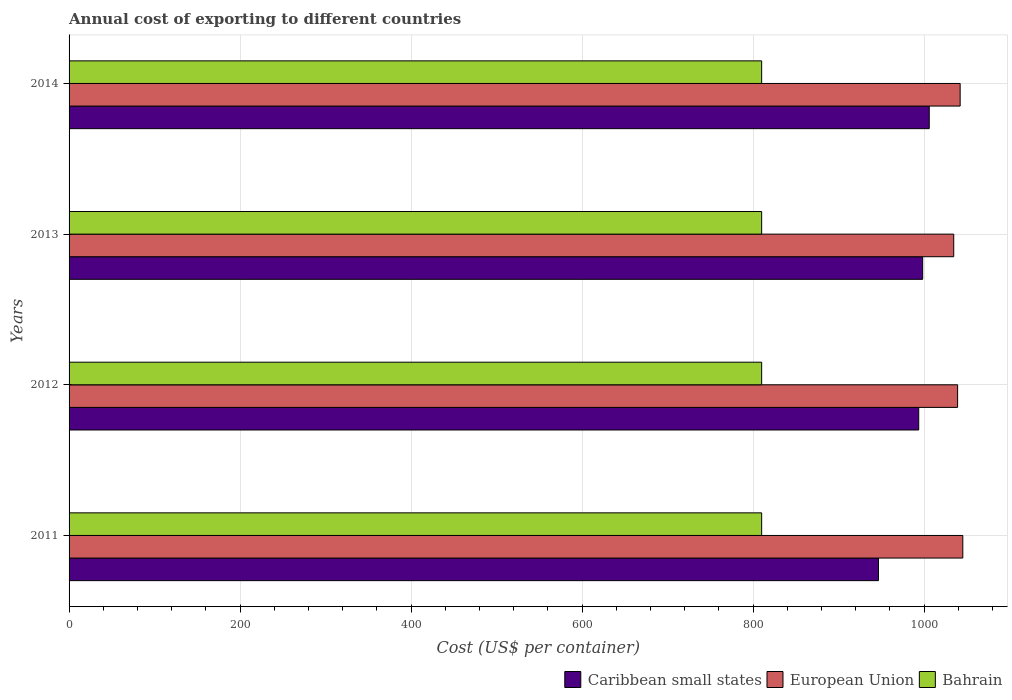How many different coloured bars are there?
Offer a terse response. 3. Are the number of bars per tick equal to the number of legend labels?
Offer a very short reply. Yes. How many bars are there on the 1st tick from the top?
Offer a very short reply. 3. How many bars are there on the 1st tick from the bottom?
Your answer should be very brief. 3. What is the label of the 2nd group of bars from the top?
Give a very brief answer. 2013. In how many cases, is the number of bars for a given year not equal to the number of legend labels?
Your answer should be very brief. 0. What is the total annual cost of exporting in European Union in 2012?
Ensure brevity in your answer.  1039.18. Across all years, what is the maximum total annual cost of exporting in Caribbean small states?
Provide a short and direct response. 1006. Across all years, what is the minimum total annual cost of exporting in Bahrain?
Provide a succinct answer. 810. In which year was the total annual cost of exporting in Caribbean small states maximum?
Give a very brief answer. 2014. In which year was the total annual cost of exporting in Bahrain minimum?
Offer a terse response. 2011. What is the total total annual cost of exporting in Bahrain in the graph?
Your response must be concise. 3240. What is the difference between the total annual cost of exporting in European Union in 2011 and that in 2014?
Your response must be concise. 3.11. What is the difference between the total annual cost of exporting in European Union in 2014 and the total annual cost of exporting in Caribbean small states in 2012?
Make the answer very short. 48.45. What is the average total annual cost of exporting in Bahrain per year?
Provide a succinct answer. 810. In the year 2011, what is the difference between the total annual cost of exporting in Bahrain and total annual cost of exporting in European Union?
Make the answer very short. -235.25. In how many years, is the total annual cost of exporting in Caribbean small states greater than 360 US$?
Give a very brief answer. 4. What is the ratio of the total annual cost of exporting in Caribbean small states in 2012 to that in 2014?
Your answer should be very brief. 0.99. What is the difference between the highest and the second highest total annual cost of exporting in European Union?
Your answer should be compact. 3.11. What is the difference between the highest and the lowest total annual cost of exporting in European Union?
Ensure brevity in your answer.  10.61. Is the sum of the total annual cost of exporting in Caribbean small states in 2011 and 2012 greater than the maximum total annual cost of exporting in European Union across all years?
Your answer should be very brief. Yes. What does the 3rd bar from the top in 2013 represents?
Your answer should be very brief. Caribbean small states. What does the 2nd bar from the bottom in 2013 represents?
Provide a short and direct response. European Union. What is the difference between two consecutive major ticks on the X-axis?
Provide a succinct answer. 200. Does the graph contain grids?
Your answer should be compact. Yes. Where does the legend appear in the graph?
Offer a very short reply. Bottom right. How are the legend labels stacked?
Your response must be concise. Horizontal. What is the title of the graph?
Your answer should be very brief. Annual cost of exporting to different countries. Does "Malawi" appear as one of the legend labels in the graph?
Make the answer very short. No. What is the label or title of the X-axis?
Ensure brevity in your answer.  Cost (US$ per container). What is the label or title of the Y-axis?
Give a very brief answer. Years. What is the Cost (US$ per container) in Caribbean small states in 2011?
Give a very brief answer. 946.62. What is the Cost (US$ per container) in European Union in 2011?
Give a very brief answer. 1045.25. What is the Cost (US$ per container) in Bahrain in 2011?
Keep it short and to the point. 810. What is the Cost (US$ per container) of Caribbean small states in 2012?
Provide a succinct answer. 993.69. What is the Cost (US$ per container) of European Union in 2012?
Offer a very short reply. 1039.18. What is the Cost (US$ per container) of Bahrain in 2012?
Your answer should be very brief. 810. What is the Cost (US$ per container) of Caribbean small states in 2013?
Your answer should be compact. 998.31. What is the Cost (US$ per container) of European Union in 2013?
Keep it short and to the point. 1034.64. What is the Cost (US$ per container) in Bahrain in 2013?
Provide a succinct answer. 810. What is the Cost (US$ per container) in Caribbean small states in 2014?
Your answer should be compact. 1006. What is the Cost (US$ per container) of European Union in 2014?
Keep it short and to the point. 1042.14. What is the Cost (US$ per container) of Bahrain in 2014?
Ensure brevity in your answer.  810. Across all years, what is the maximum Cost (US$ per container) in Caribbean small states?
Ensure brevity in your answer.  1006. Across all years, what is the maximum Cost (US$ per container) in European Union?
Keep it short and to the point. 1045.25. Across all years, what is the maximum Cost (US$ per container) of Bahrain?
Ensure brevity in your answer.  810. Across all years, what is the minimum Cost (US$ per container) in Caribbean small states?
Make the answer very short. 946.62. Across all years, what is the minimum Cost (US$ per container) of European Union?
Your answer should be very brief. 1034.64. Across all years, what is the minimum Cost (US$ per container) in Bahrain?
Your answer should be compact. 810. What is the total Cost (US$ per container) in Caribbean small states in the graph?
Offer a very short reply. 3944.62. What is the total Cost (US$ per container) of European Union in the graph?
Offer a very short reply. 4161.21. What is the total Cost (US$ per container) in Bahrain in the graph?
Give a very brief answer. 3240. What is the difference between the Cost (US$ per container) in Caribbean small states in 2011 and that in 2012?
Offer a very short reply. -47.08. What is the difference between the Cost (US$ per container) in European Union in 2011 and that in 2012?
Make the answer very short. 6.07. What is the difference between the Cost (US$ per container) in Bahrain in 2011 and that in 2012?
Offer a very short reply. 0. What is the difference between the Cost (US$ per container) in Caribbean small states in 2011 and that in 2013?
Provide a succinct answer. -51.69. What is the difference between the Cost (US$ per container) of European Union in 2011 and that in 2013?
Ensure brevity in your answer.  10.61. What is the difference between the Cost (US$ per container) of Bahrain in 2011 and that in 2013?
Your answer should be very brief. 0. What is the difference between the Cost (US$ per container) of Caribbean small states in 2011 and that in 2014?
Provide a succinct answer. -59.38. What is the difference between the Cost (US$ per container) of European Union in 2011 and that in 2014?
Keep it short and to the point. 3.11. What is the difference between the Cost (US$ per container) in Caribbean small states in 2012 and that in 2013?
Offer a terse response. -4.62. What is the difference between the Cost (US$ per container) in European Union in 2012 and that in 2013?
Offer a very short reply. 4.54. What is the difference between the Cost (US$ per container) of Bahrain in 2012 and that in 2013?
Your response must be concise. 0. What is the difference between the Cost (US$ per container) of Caribbean small states in 2012 and that in 2014?
Make the answer very short. -12.31. What is the difference between the Cost (US$ per container) in European Union in 2012 and that in 2014?
Make the answer very short. -2.96. What is the difference between the Cost (US$ per container) in Bahrain in 2012 and that in 2014?
Offer a terse response. 0. What is the difference between the Cost (US$ per container) of Caribbean small states in 2013 and that in 2014?
Provide a short and direct response. -7.69. What is the difference between the Cost (US$ per container) in Bahrain in 2013 and that in 2014?
Keep it short and to the point. 0. What is the difference between the Cost (US$ per container) in Caribbean small states in 2011 and the Cost (US$ per container) in European Union in 2012?
Ensure brevity in your answer.  -92.56. What is the difference between the Cost (US$ per container) in Caribbean small states in 2011 and the Cost (US$ per container) in Bahrain in 2012?
Your response must be concise. 136.62. What is the difference between the Cost (US$ per container) of European Union in 2011 and the Cost (US$ per container) of Bahrain in 2012?
Offer a very short reply. 235.25. What is the difference between the Cost (US$ per container) of Caribbean small states in 2011 and the Cost (US$ per container) of European Union in 2013?
Provide a succinct answer. -88.03. What is the difference between the Cost (US$ per container) in Caribbean small states in 2011 and the Cost (US$ per container) in Bahrain in 2013?
Provide a succinct answer. 136.62. What is the difference between the Cost (US$ per container) in European Union in 2011 and the Cost (US$ per container) in Bahrain in 2013?
Keep it short and to the point. 235.25. What is the difference between the Cost (US$ per container) of Caribbean small states in 2011 and the Cost (US$ per container) of European Union in 2014?
Your answer should be very brief. -95.53. What is the difference between the Cost (US$ per container) in Caribbean small states in 2011 and the Cost (US$ per container) in Bahrain in 2014?
Your answer should be very brief. 136.62. What is the difference between the Cost (US$ per container) of European Union in 2011 and the Cost (US$ per container) of Bahrain in 2014?
Your answer should be compact. 235.25. What is the difference between the Cost (US$ per container) in Caribbean small states in 2012 and the Cost (US$ per container) in European Union in 2013?
Give a very brief answer. -40.95. What is the difference between the Cost (US$ per container) in Caribbean small states in 2012 and the Cost (US$ per container) in Bahrain in 2013?
Ensure brevity in your answer.  183.69. What is the difference between the Cost (US$ per container) in European Union in 2012 and the Cost (US$ per container) in Bahrain in 2013?
Make the answer very short. 229.18. What is the difference between the Cost (US$ per container) in Caribbean small states in 2012 and the Cost (US$ per container) in European Union in 2014?
Offer a terse response. -48.45. What is the difference between the Cost (US$ per container) in Caribbean small states in 2012 and the Cost (US$ per container) in Bahrain in 2014?
Your answer should be very brief. 183.69. What is the difference between the Cost (US$ per container) in European Union in 2012 and the Cost (US$ per container) in Bahrain in 2014?
Keep it short and to the point. 229.18. What is the difference between the Cost (US$ per container) of Caribbean small states in 2013 and the Cost (US$ per container) of European Union in 2014?
Offer a very short reply. -43.84. What is the difference between the Cost (US$ per container) of Caribbean small states in 2013 and the Cost (US$ per container) of Bahrain in 2014?
Provide a short and direct response. 188.31. What is the difference between the Cost (US$ per container) of European Union in 2013 and the Cost (US$ per container) of Bahrain in 2014?
Offer a very short reply. 224.64. What is the average Cost (US$ per container) in Caribbean small states per year?
Your answer should be compact. 986.15. What is the average Cost (US$ per container) in European Union per year?
Ensure brevity in your answer.  1040.3. What is the average Cost (US$ per container) in Bahrain per year?
Give a very brief answer. 810. In the year 2011, what is the difference between the Cost (US$ per container) of Caribbean small states and Cost (US$ per container) of European Union?
Your answer should be compact. -98.63. In the year 2011, what is the difference between the Cost (US$ per container) of Caribbean small states and Cost (US$ per container) of Bahrain?
Offer a very short reply. 136.62. In the year 2011, what is the difference between the Cost (US$ per container) of European Union and Cost (US$ per container) of Bahrain?
Ensure brevity in your answer.  235.25. In the year 2012, what is the difference between the Cost (US$ per container) of Caribbean small states and Cost (US$ per container) of European Union?
Keep it short and to the point. -45.49. In the year 2012, what is the difference between the Cost (US$ per container) of Caribbean small states and Cost (US$ per container) of Bahrain?
Keep it short and to the point. 183.69. In the year 2012, what is the difference between the Cost (US$ per container) in European Union and Cost (US$ per container) in Bahrain?
Offer a very short reply. 229.18. In the year 2013, what is the difference between the Cost (US$ per container) of Caribbean small states and Cost (US$ per container) of European Union?
Give a very brief answer. -36.34. In the year 2013, what is the difference between the Cost (US$ per container) of Caribbean small states and Cost (US$ per container) of Bahrain?
Ensure brevity in your answer.  188.31. In the year 2013, what is the difference between the Cost (US$ per container) of European Union and Cost (US$ per container) of Bahrain?
Offer a very short reply. 224.64. In the year 2014, what is the difference between the Cost (US$ per container) in Caribbean small states and Cost (US$ per container) in European Union?
Offer a very short reply. -36.14. In the year 2014, what is the difference between the Cost (US$ per container) in Caribbean small states and Cost (US$ per container) in Bahrain?
Your answer should be very brief. 196. In the year 2014, what is the difference between the Cost (US$ per container) in European Union and Cost (US$ per container) in Bahrain?
Give a very brief answer. 232.14. What is the ratio of the Cost (US$ per container) in Caribbean small states in 2011 to that in 2012?
Provide a succinct answer. 0.95. What is the ratio of the Cost (US$ per container) of European Union in 2011 to that in 2012?
Your response must be concise. 1.01. What is the ratio of the Cost (US$ per container) of Bahrain in 2011 to that in 2012?
Provide a succinct answer. 1. What is the ratio of the Cost (US$ per container) in Caribbean small states in 2011 to that in 2013?
Provide a succinct answer. 0.95. What is the ratio of the Cost (US$ per container) of European Union in 2011 to that in 2013?
Your response must be concise. 1.01. What is the ratio of the Cost (US$ per container) in Caribbean small states in 2011 to that in 2014?
Provide a succinct answer. 0.94. What is the ratio of the Cost (US$ per container) of European Union in 2011 to that in 2014?
Ensure brevity in your answer.  1. What is the ratio of the Cost (US$ per container) of Caribbean small states in 2012 to that in 2013?
Ensure brevity in your answer.  1. What is the ratio of the Cost (US$ per container) in European Union in 2012 to that in 2013?
Your response must be concise. 1. What is the ratio of the Cost (US$ per container) in Bahrain in 2012 to that in 2013?
Your answer should be compact. 1. What is the ratio of the Cost (US$ per container) of Bahrain in 2012 to that in 2014?
Keep it short and to the point. 1. What is the ratio of the Cost (US$ per container) in Bahrain in 2013 to that in 2014?
Your answer should be very brief. 1. What is the difference between the highest and the second highest Cost (US$ per container) in Caribbean small states?
Give a very brief answer. 7.69. What is the difference between the highest and the second highest Cost (US$ per container) in European Union?
Offer a very short reply. 3.11. What is the difference between the highest and the second highest Cost (US$ per container) in Bahrain?
Offer a terse response. 0. What is the difference between the highest and the lowest Cost (US$ per container) in Caribbean small states?
Your answer should be very brief. 59.38. What is the difference between the highest and the lowest Cost (US$ per container) of European Union?
Provide a succinct answer. 10.61. 